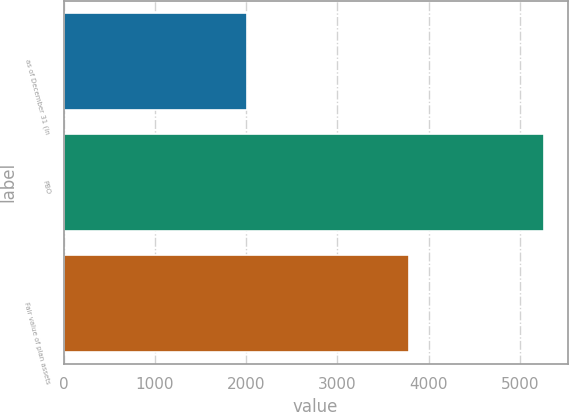<chart> <loc_0><loc_0><loc_500><loc_500><bar_chart><fcel>as of December 31 (in<fcel>PBO<fcel>Fair value of plan assets<nl><fcel>2013<fcel>5260<fcel>3785<nl></chart> 